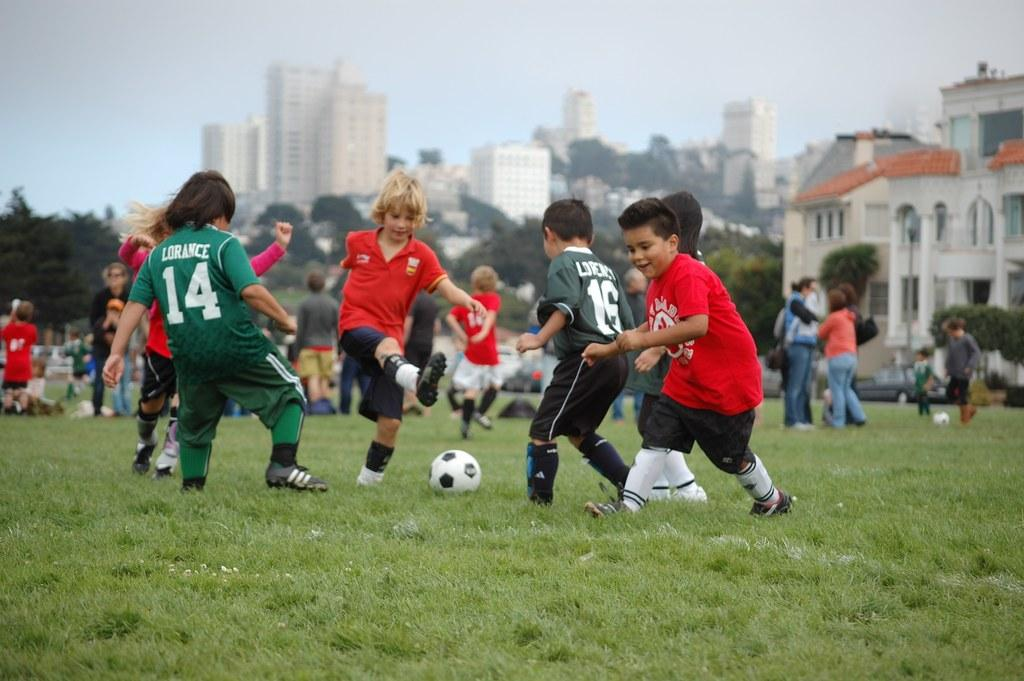<image>
Present a compact description of the photo's key features. A kid in the number 16 jersey is trying to make a play on the ball. 